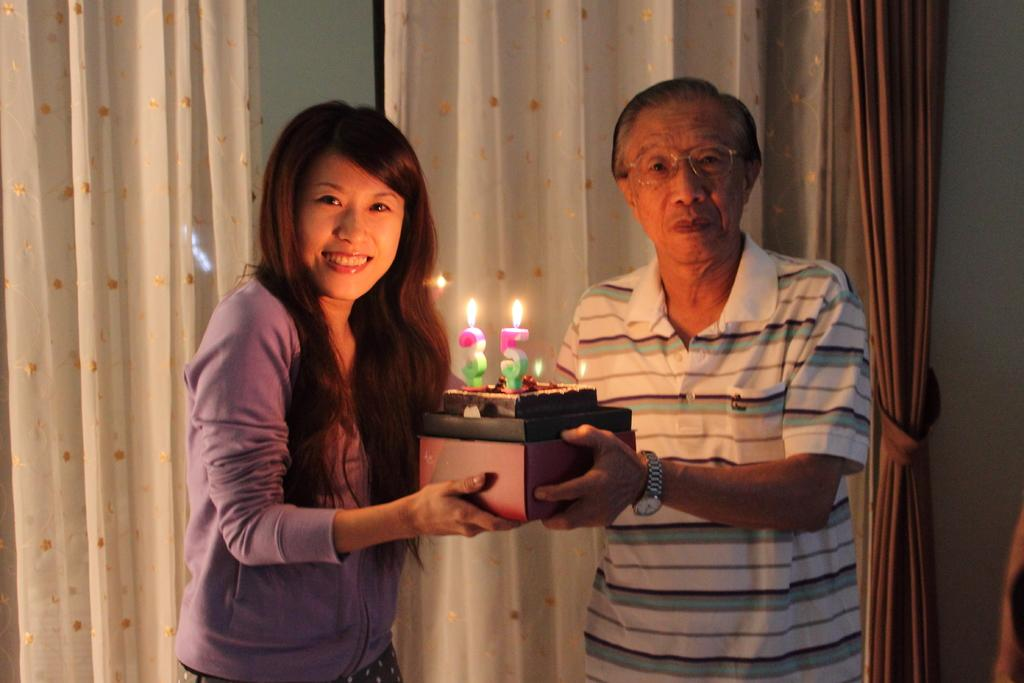How many people are in the image? There are two persons in the image. What are the two persons holding? The two persons are holding a box. What is on top of the box? There is a cake on the box. What is on the cake? There are candles on the cake. What can be seen in the background of the image? There are curtains and a wall in the background of the image. What type of chain is being used to hold the wine in the image? There is no chain or wine present in the image. What topic are the two persons discussing in the image? The image does not show any discussion or conversation between the two persons. 